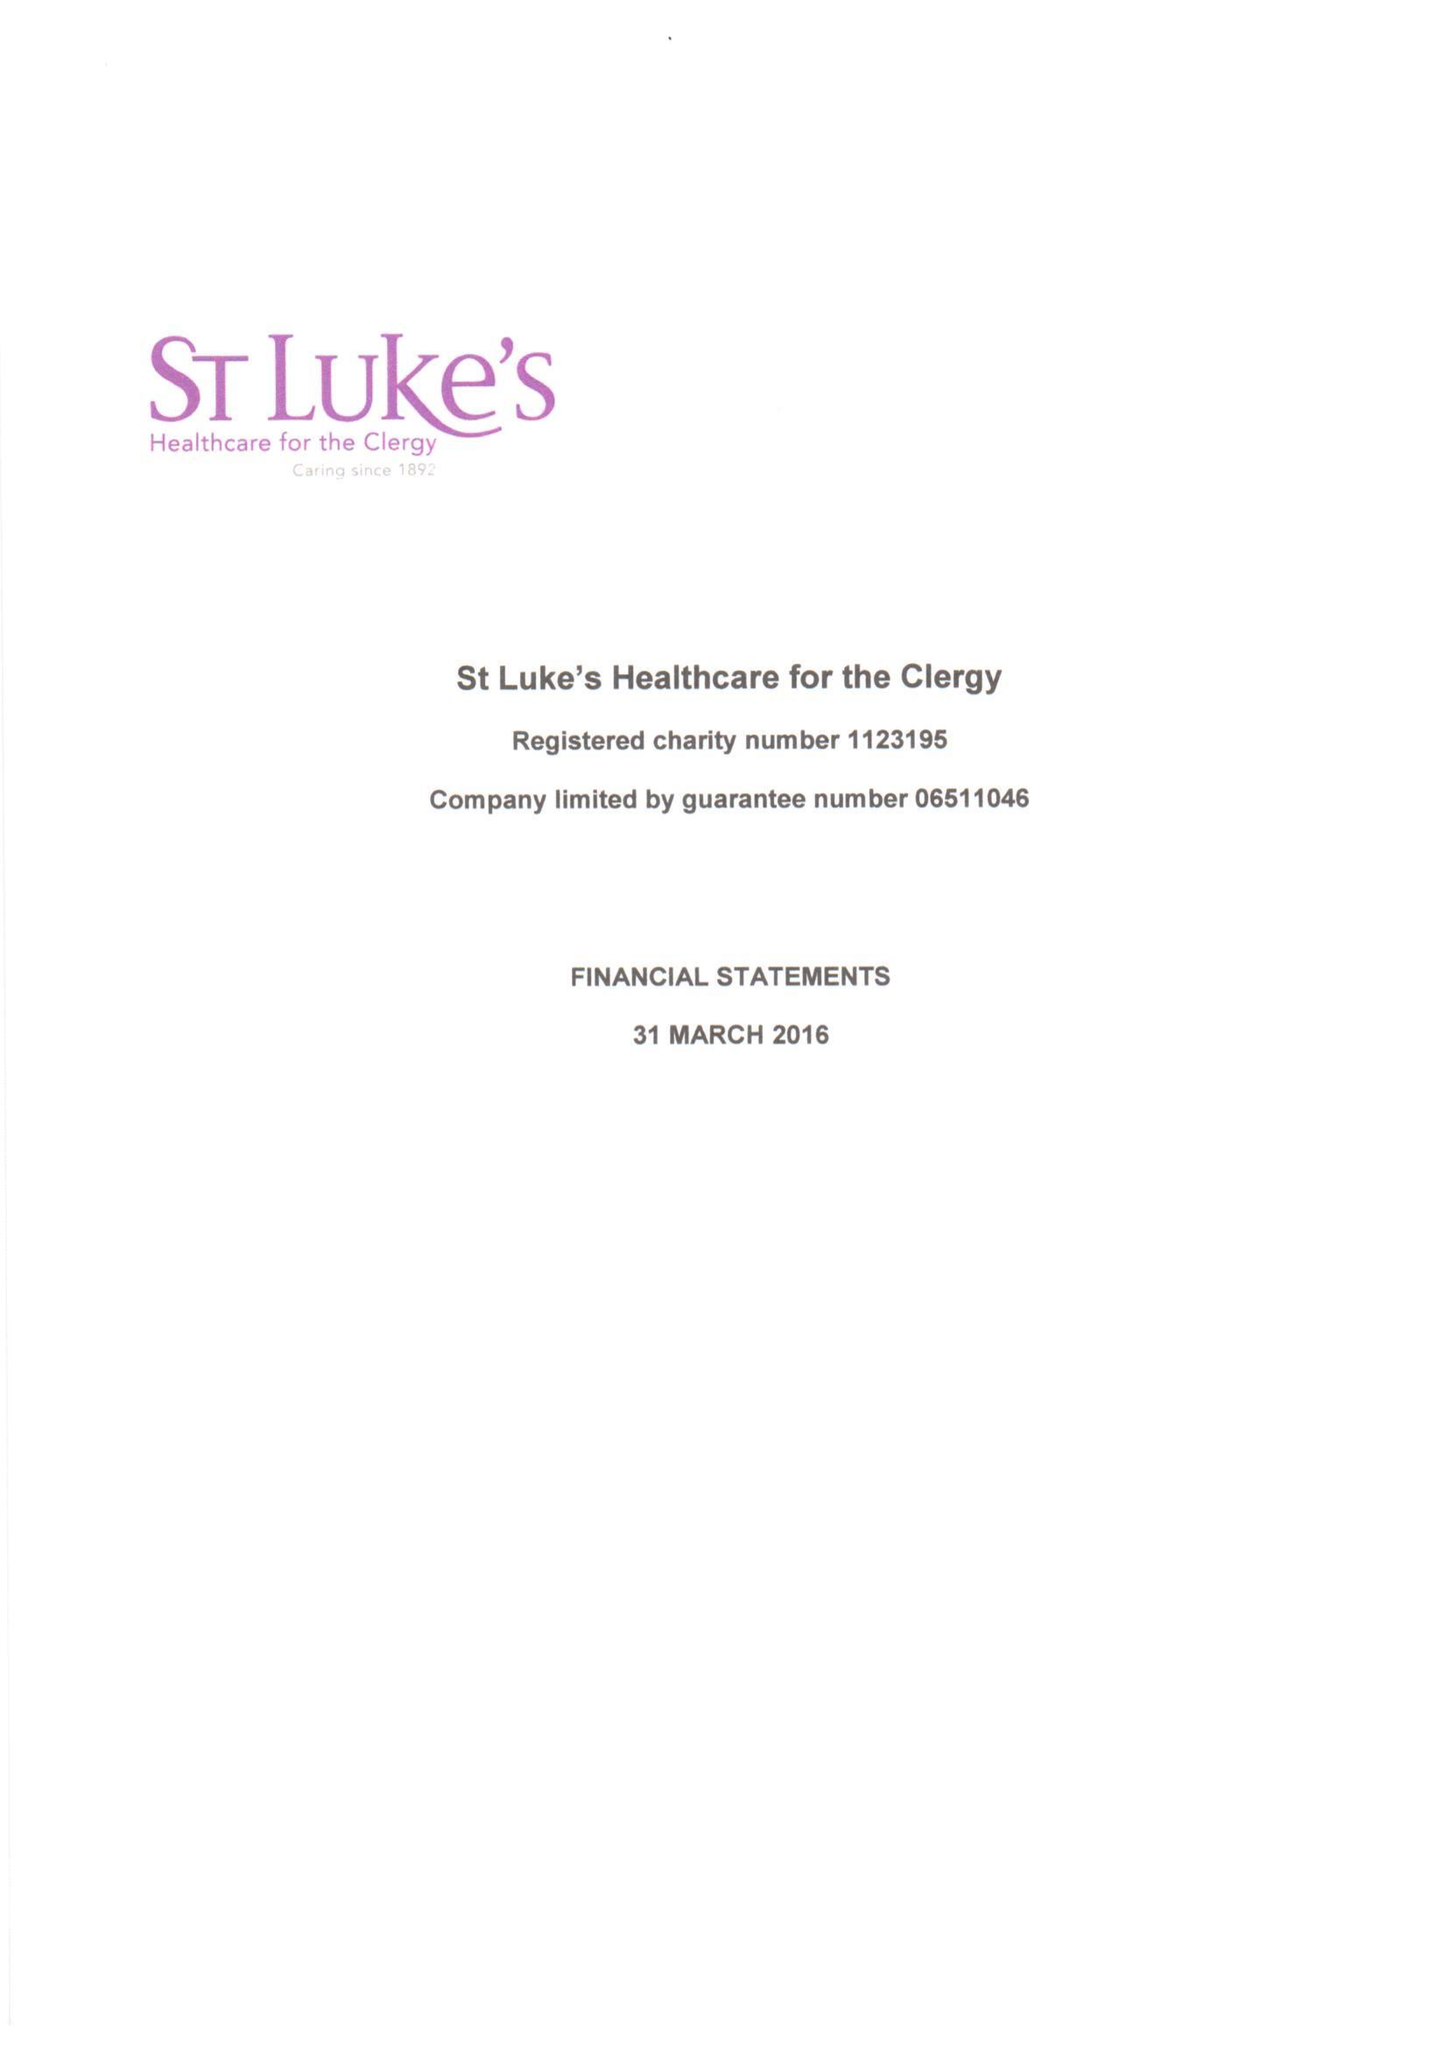What is the value for the address__post_town?
Answer the question using a single word or phrase. LONDON 